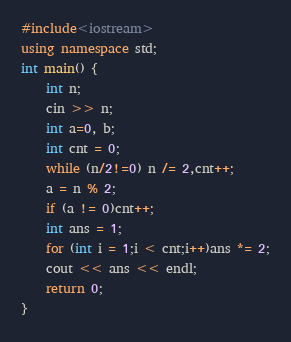<code> <loc_0><loc_0><loc_500><loc_500><_C++_>#include<iostream>
using namespace std;
int main() {
	int n;
	cin >> n;
	int a=0, b;
	int cnt = 0;
	while (n/2!=0) n /= 2,cnt++;
	a = n % 2;
	if (a != 0)cnt++;
	int ans = 1;
	for (int i = 1;i < cnt;i++)ans *= 2;
	cout << ans << endl;
	return 0;
}
</code> 